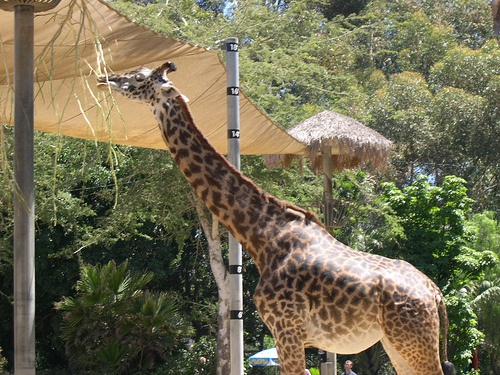Describe the objects in this image and their specific colors. I can see giraffe in maroon, gray, and black tones and people in maroon, gray, darkgray, and black tones in this image. 